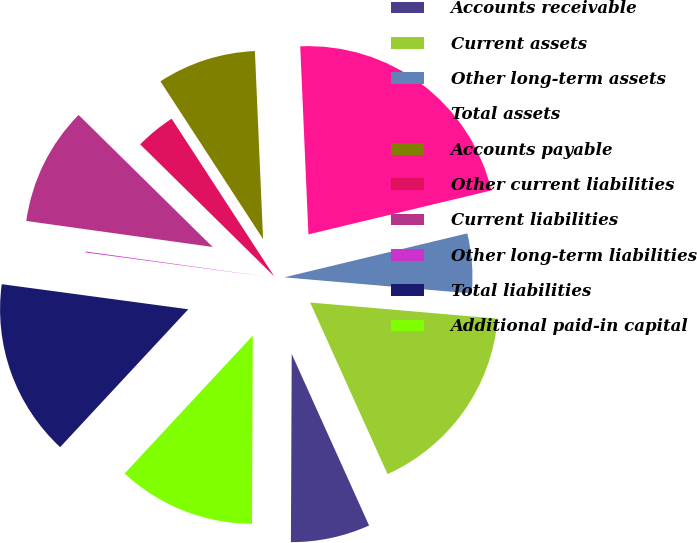Convert chart to OTSL. <chart><loc_0><loc_0><loc_500><loc_500><pie_chart><fcel>Accounts receivable<fcel>Current assets<fcel>Other long-term assets<fcel>Total assets<fcel>Accounts payable<fcel>Other current liabilities<fcel>Current liabilities<fcel>Other long-term liabilities<fcel>Total liabilities<fcel>Additional paid-in capital<nl><fcel>6.81%<fcel>16.89%<fcel>5.12%<fcel>21.94%<fcel>8.49%<fcel>3.44%<fcel>10.17%<fcel>0.08%<fcel>15.21%<fcel>11.85%<nl></chart> 